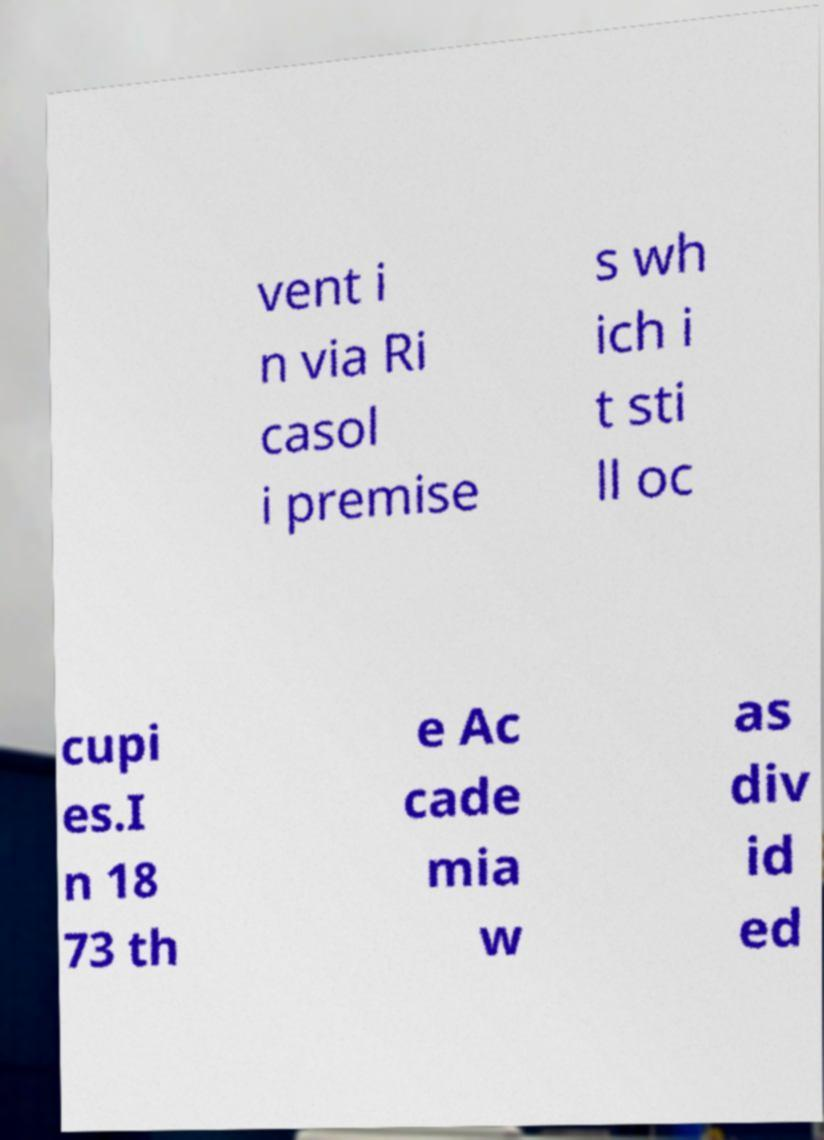Could you extract and type out the text from this image? vent i n via Ri casol i premise s wh ich i t sti ll oc cupi es.I n 18 73 th e Ac cade mia w as div id ed 